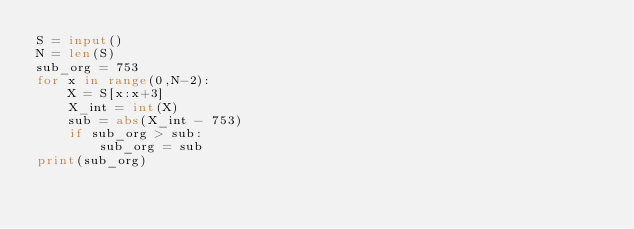Convert code to text. <code><loc_0><loc_0><loc_500><loc_500><_Python_>S = input()
N = len(S)
sub_org = 753
for x in range(0,N-2):
    X = S[x:x+3]
    X_int = int(X)
    sub = abs(X_int - 753)
    if sub_org > sub:
        sub_org = sub
print(sub_org)</code> 